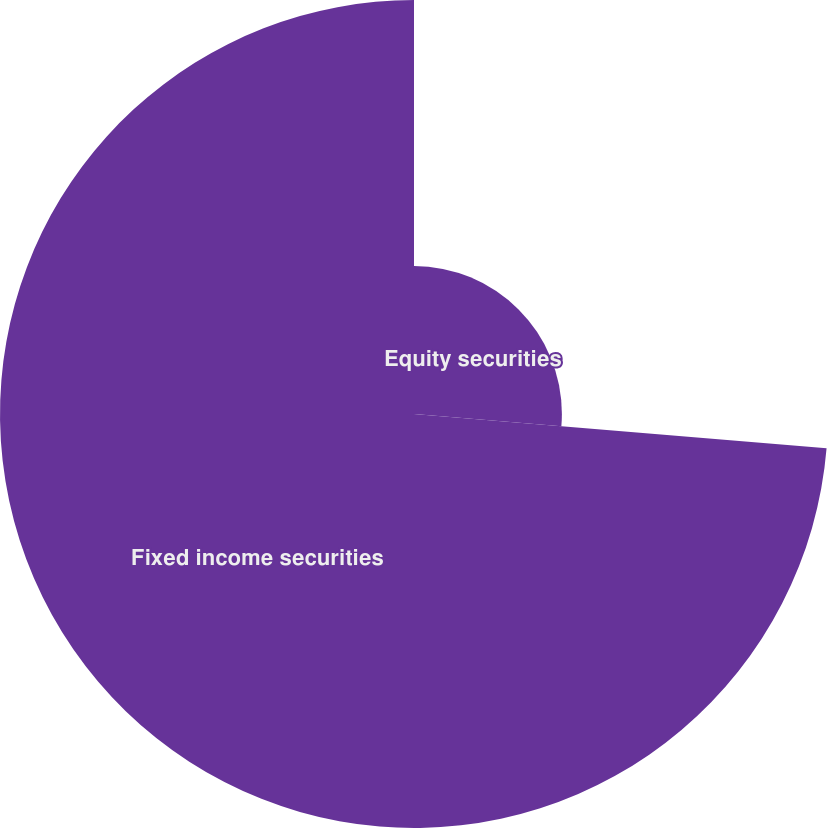<chart> <loc_0><loc_0><loc_500><loc_500><pie_chart><fcel>Equity securities<fcel>Fixed income securities<nl><fcel>26.32%<fcel>73.68%<nl></chart> 